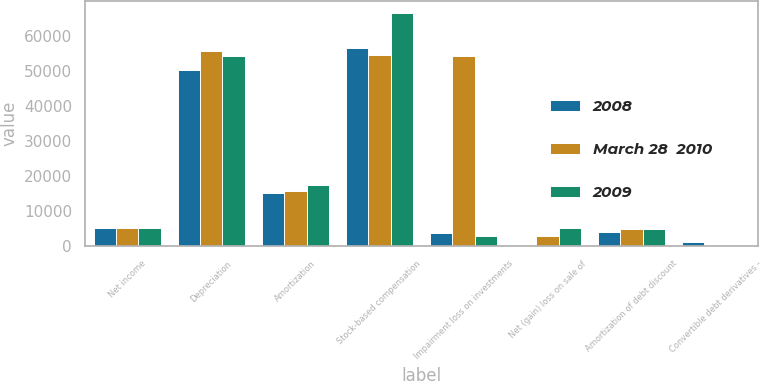Convert chart to OTSL. <chart><loc_0><loc_0><loc_500><loc_500><stacked_bar_chart><ecel><fcel>Net income<fcel>Depreciation<fcel>Amortization<fcel>Stock-based compensation<fcel>Impairment loss on investments<fcel>Net (gain) loss on sale of<fcel>Amortization of debt discount<fcel>Convertible debt derivatives -<nl><fcel>2008<fcel>5139<fcel>50180<fcel>14982<fcel>56481<fcel>3805<fcel>351<fcel>3892<fcel>1204<nl><fcel>March 28  2010<fcel>5139<fcel>55632<fcel>15682<fcel>54509<fcel>54129<fcel>2706<fcel>4789<fcel>97<nl><fcel>2009<fcel>5139<fcel>54199<fcel>17472<fcel>66427<fcel>2850<fcel>5139<fcel>4889<fcel>254<nl></chart> 